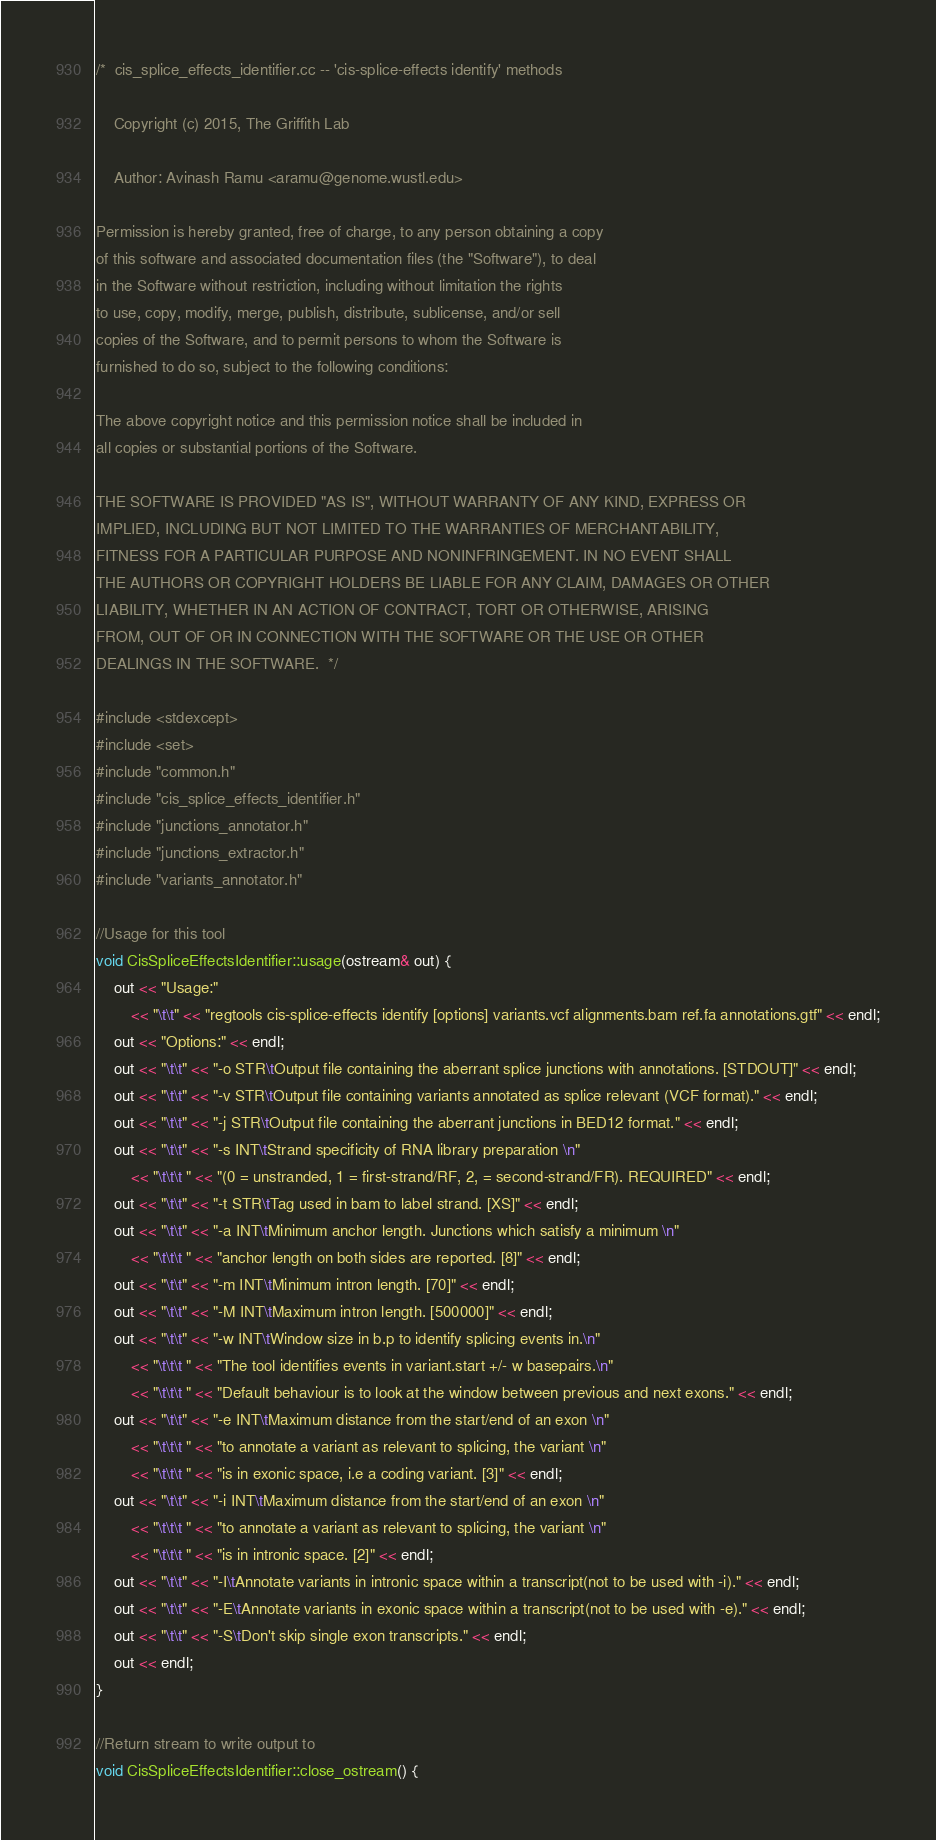<code> <loc_0><loc_0><loc_500><loc_500><_C++_>/*  cis_splice_effects_identifier.cc -- 'cis-splice-effects identify' methods

    Copyright (c) 2015, The Griffith Lab

    Author: Avinash Ramu <aramu@genome.wustl.edu>

Permission is hereby granted, free of charge, to any person obtaining a copy
of this software and associated documentation files (the "Software"), to deal
in the Software without restriction, including without limitation the rights
to use, copy, modify, merge, publish, distribute, sublicense, and/or sell
copies of the Software, and to permit persons to whom the Software is
furnished to do so, subject to the following conditions:

The above copyright notice and this permission notice shall be included in
all copies or substantial portions of the Software.

THE SOFTWARE IS PROVIDED "AS IS", WITHOUT WARRANTY OF ANY KIND, EXPRESS OR
IMPLIED, INCLUDING BUT NOT LIMITED TO THE WARRANTIES OF MERCHANTABILITY,
FITNESS FOR A PARTICULAR PURPOSE AND NONINFRINGEMENT. IN NO EVENT SHALL
THE AUTHORS OR COPYRIGHT HOLDERS BE LIABLE FOR ANY CLAIM, DAMAGES OR OTHER
LIABILITY, WHETHER IN AN ACTION OF CONTRACT, TORT OR OTHERWISE, ARISING
FROM, OUT OF OR IN CONNECTION WITH THE SOFTWARE OR THE USE OR OTHER
DEALINGS IN THE SOFTWARE.  */

#include <stdexcept>
#include <set>
#include "common.h"
#include "cis_splice_effects_identifier.h"
#include "junctions_annotator.h"
#include "junctions_extractor.h"
#include "variants_annotator.h"

//Usage for this tool
void CisSpliceEffectsIdentifier::usage(ostream& out) {
    out << "Usage:" 
        << "\t\t" << "regtools cis-splice-effects identify [options] variants.vcf alignments.bam ref.fa annotations.gtf" << endl;
    out << "Options:" << endl;
    out << "\t\t" << "-o STR\tOutput file containing the aberrant splice junctions with annotations. [STDOUT]" << endl;
    out << "\t\t" << "-v STR\tOutput file containing variants annotated as splice relevant (VCF format)." << endl;
    out << "\t\t" << "-j STR\tOutput file containing the aberrant junctions in BED12 format." << endl;
    out << "\t\t" << "-s INT\tStrand specificity of RNA library preparation \n"
        << "\t\t\t " << "(0 = unstranded, 1 = first-strand/RF, 2, = second-strand/FR). REQUIRED" << endl;
    out << "\t\t" << "-t STR\tTag used in bam to label strand. [XS]" << endl;
    out << "\t\t" << "-a INT\tMinimum anchor length. Junctions which satisfy a minimum \n"
        << "\t\t\t " << "anchor length on both sides are reported. [8]" << endl;
    out << "\t\t" << "-m INT\tMinimum intron length. [70]" << endl;
    out << "\t\t" << "-M INT\tMaximum intron length. [500000]" << endl;
    out << "\t\t" << "-w INT\tWindow size in b.p to identify splicing events in.\n" 
        << "\t\t\t " << "The tool identifies events in variant.start +/- w basepairs.\n"
        << "\t\t\t " << "Default behaviour is to look at the window between previous and next exons." << endl;
    out << "\t\t" << "-e INT\tMaximum distance from the start/end of an exon \n"
        << "\t\t\t " << "to annotate a variant as relevant to splicing, the variant \n"
        << "\t\t\t " << "is in exonic space, i.e a coding variant. [3]" << endl;
    out << "\t\t" << "-i INT\tMaximum distance from the start/end of an exon \n"
        << "\t\t\t " << "to annotate a variant as relevant to splicing, the variant \n"
        << "\t\t\t " << "is in intronic space. [2]" << endl;
    out << "\t\t" << "-I\tAnnotate variants in intronic space within a transcript(not to be used with -i)." << endl;
    out << "\t\t" << "-E\tAnnotate variants in exonic space within a transcript(not to be used with -e)." << endl;
    out << "\t\t" << "-S\tDon't skip single exon transcripts." << endl;
    out << endl;
}

//Return stream to write output to
void CisSpliceEffectsIdentifier::close_ostream() {</code> 